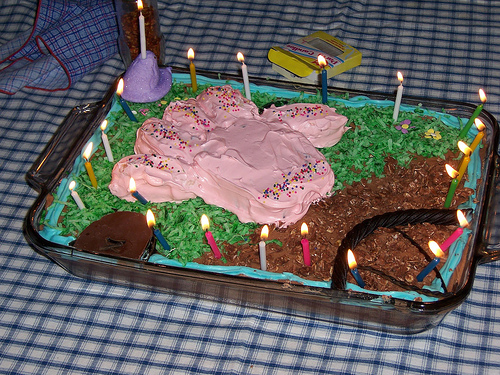<image>
Can you confirm if the cake is behind the candles? No. The cake is not behind the candles. From this viewpoint, the cake appears to be positioned elsewhere in the scene. Is the candle above the cake? Yes. The candle is positioned above the cake in the vertical space, higher up in the scene. 